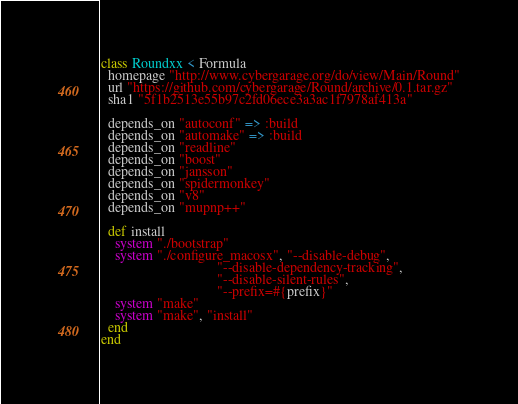<code> <loc_0><loc_0><loc_500><loc_500><_Ruby_>class Roundxx < Formula
  homepage "http://www.cybergarage.org/do/view/Main/Round"
  url "https://github.com/cybergarage/Round/archive/0.1.tar.gz"
  sha1 "5f1b2513e55b97c2fd06ece3a3ac1f7978af413a"

  depends_on "autoconf" => :build
  depends_on "automake" => :build
  depends_on "readline" 
  depends_on "boost"   
  depends_on "jansson"
  depends_on "spidermonkey"
  depends_on "v8"
  depends_on "mupnp++"

  def install
    system "./bootstrap"
    system "./configure_macosx", "--disable-debug",
                                 "--disable-dependency-tracking",
                                 "--disable-silent-rules",
                                 "--prefix=#{prefix}"
    system "make"
    system "make", "install"
  end
end
</code> 